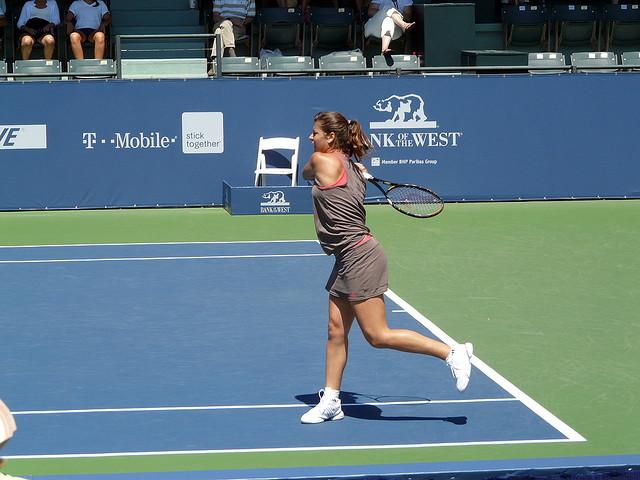What color is the court?
Short answer required. Blue. What color are her shoes?
Answer briefly. White. What color is the tennis player shorts?
Write a very short answer. Gray. What game is she playing?
Be succinct. Tennis. Has the girl hit the ball yet?
Write a very short answer. Yes. 